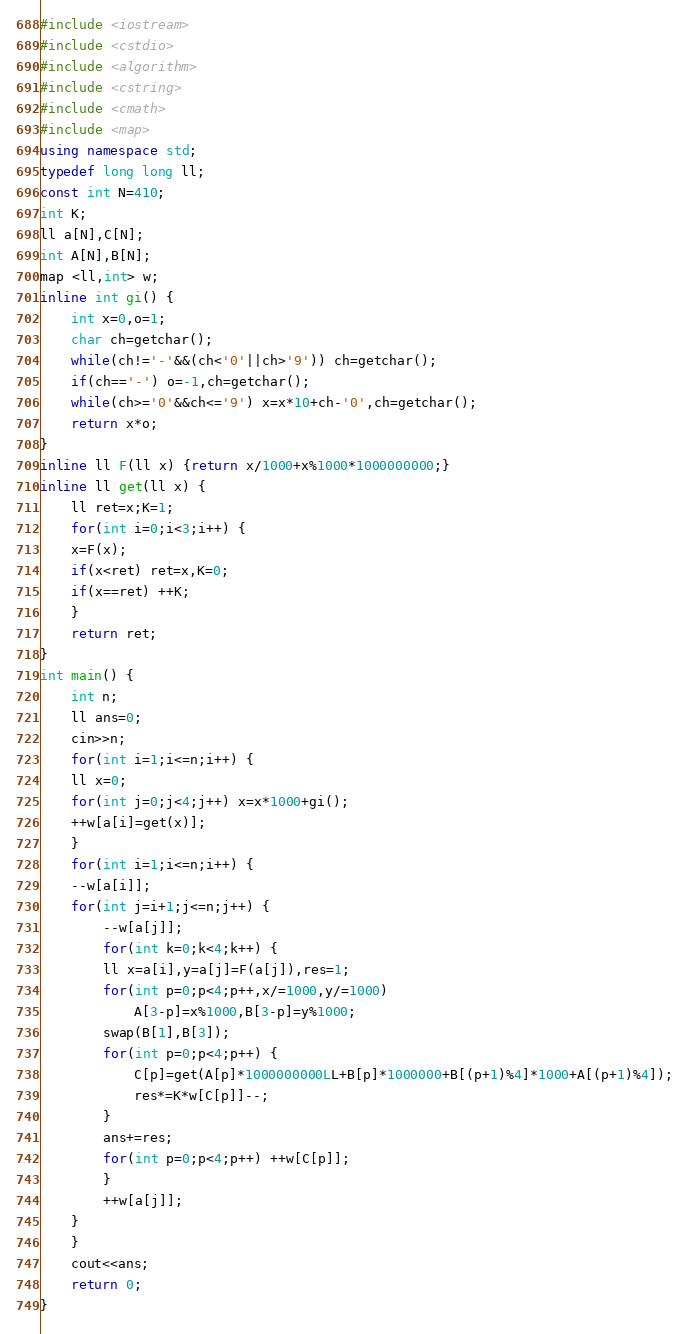<code> <loc_0><loc_0><loc_500><loc_500><_C++_>#include <iostream>
#include <cstdio>
#include <algorithm>
#include <cstring>
#include <cmath>
#include <map>
using namespace std;
typedef long long ll;
const int N=410;
int K;
ll a[N],C[N];
int A[N],B[N];
map <ll,int> w;
inline int gi() {
    int x=0,o=1;
    char ch=getchar();
    while(ch!='-'&&(ch<'0'||ch>'9')) ch=getchar();
    if(ch=='-') o=-1,ch=getchar();
    while(ch>='0'&&ch<='9') x=x*10+ch-'0',ch=getchar();
    return x*o;
}
inline ll F(ll x) {return x/1000+x%1000*1000000000;}
inline ll get(ll x) {
    ll ret=x;K=1;
    for(int i=0;i<3;i++) {
	x=F(x);
	if(x<ret) ret=x,K=0;
	if(x==ret) ++K;
    }
    return ret;
}
int main() {
    int n;
    ll ans=0;
    cin>>n;
    for(int i=1;i<=n;i++) {
	ll x=0;
	for(int j=0;j<4;j++) x=x*1000+gi();
	++w[a[i]=get(x)];
    }
    for(int i=1;i<=n;i++) {
	--w[a[i]];
	for(int j=i+1;j<=n;j++) {
	    --w[a[j]];
	    for(int k=0;k<4;k++) {
		ll x=a[i],y=a[j]=F(a[j]),res=1;
		for(int p=0;p<4;p++,x/=1000,y/=1000)
		    A[3-p]=x%1000,B[3-p]=y%1000;
		swap(B[1],B[3]);
		for(int p=0;p<4;p++) {
		    C[p]=get(A[p]*1000000000LL+B[p]*1000000+B[(p+1)%4]*1000+A[(p+1)%4]);
		    res*=K*w[C[p]]--;
		}
		ans+=res;
		for(int p=0;p<4;p++) ++w[C[p]];
	    }
	    ++w[a[j]];
	}
    }
    cout<<ans;
    return 0;
}</code> 